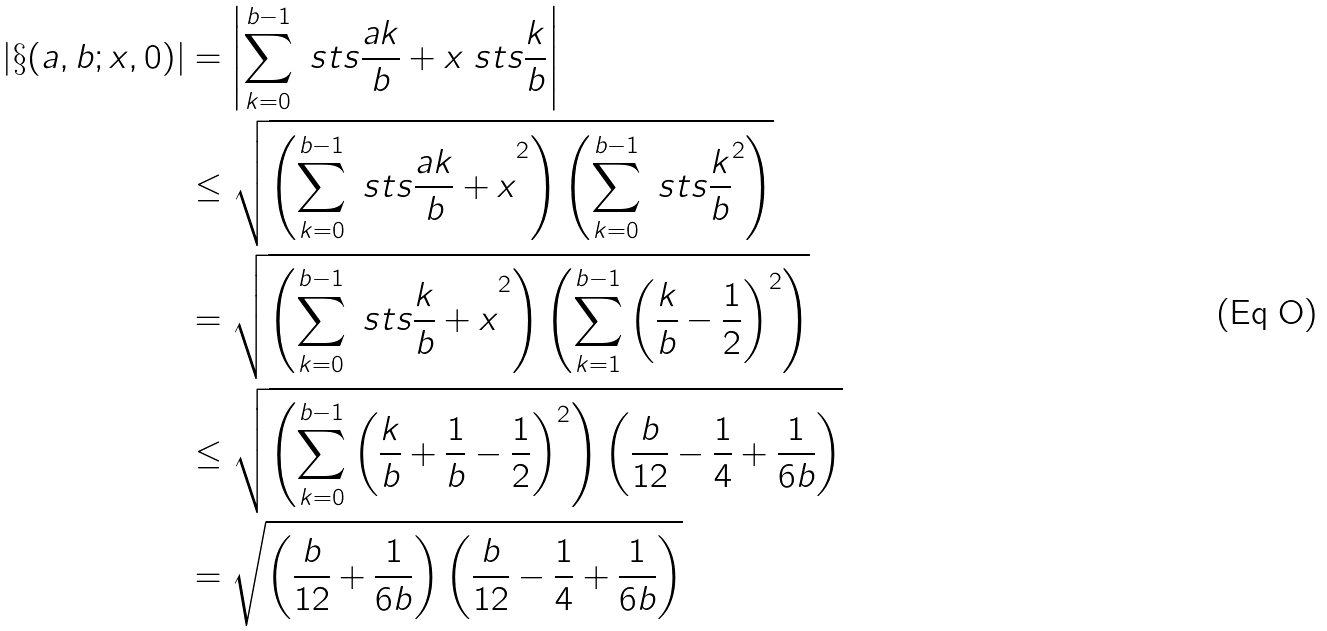<formula> <loc_0><loc_0><loc_500><loc_500>\left | \S ( a , b ; x , 0 ) \right | & = \left | \sum _ { k = 0 } ^ { b - 1 } \ s t s { \frac { a k } { b } + x } \ s t s { \frac { k } { b } } \right | \\ & \leq \sqrt { \left ( \sum _ { k = 0 } ^ { b - 1 } { \ s t s { \frac { a k } { b } + x } } ^ { 2 } \right ) \left ( \sum _ { k = 0 } ^ { b - 1 } { \ s t s { \frac { k } { b } } } ^ { 2 } \right ) } \\ & = \sqrt { \left ( \sum _ { k = 0 } ^ { b - 1 } { \ s t s { \frac { k } { b } + x } } ^ { 2 } \right ) \left ( \sum _ { k = 1 } ^ { b - 1 } \left ( \frac { k } { b } - \frac { 1 } { 2 } \right ) ^ { 2 } \right ) } \\ & \leq \sqrt { \left ( \sum _ { k = 0 } ^ { b - 1 } \left ( \frac { k } { b } + \frac { 1 } { b } - \frac { 1 } { 2 } \right ) ^ { 2 } \right ) \left ( \frac { b } { 1 2 } - \frac { 1 } { 4 } + \frac { 1 } { 6 b } \right ) } \\ & = \sqrt { \left ( \frac { b } { 1 2 } + \frac { 1 } { 6 b } \right ) \left ( \frac { b } { 1 2 } - \frac { 1 } { 4 } + \frac { 1 } { 6 b } \right ) }</formula> 